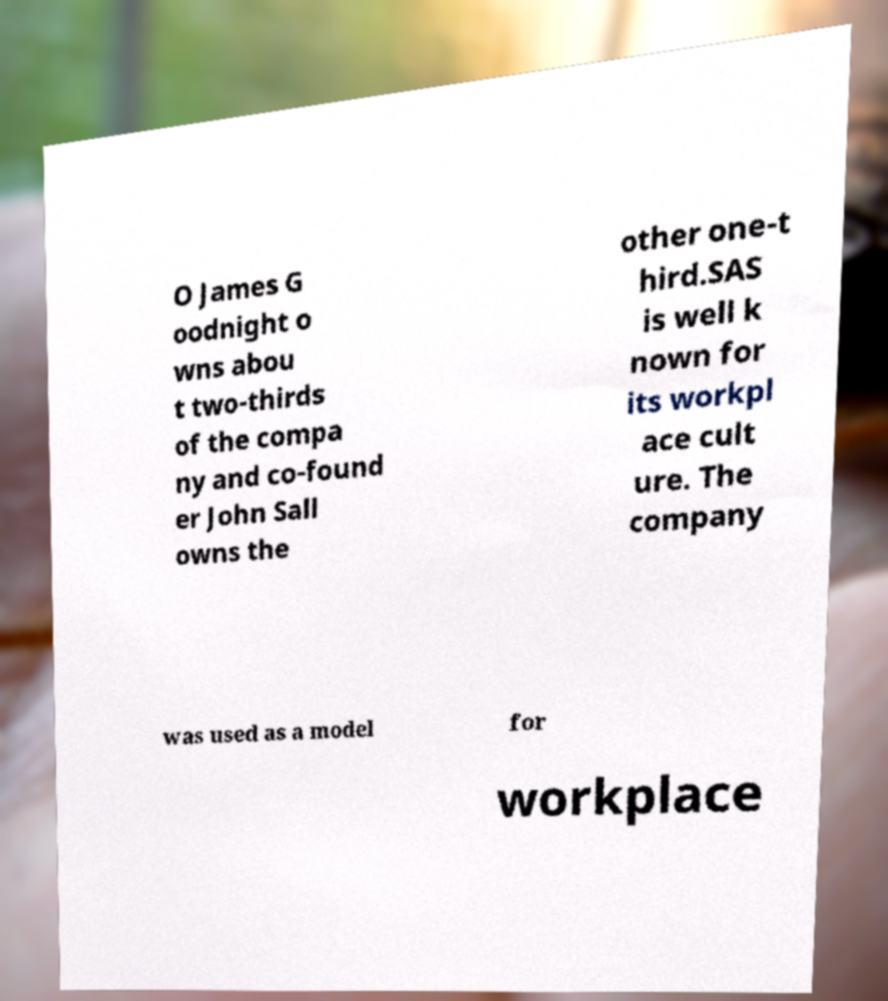Please identify and transcribe the text found in this image. O James G oodnight o wns abou t two-thirds of the compa ny and co-found er John Sall owns the other one-t hird.SAS is well k nown for its workpl ace cult ure. The company was used as a model for workplace 